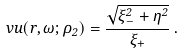Convert formula to latex. <formula><loc_0><loc_0><loc_500><loc_500>\ v u ( r , \omega ; \rho _ { 2 } ) = \frac { \sqrt { \xi _ { - } ^ { 2 } + \eta ^ { 2 } } } { \xi _ { + } } \, .</formula> 